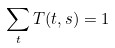<formula> <loc_0><loc_0><loc_500><loc_500>\sum _ { t } T ( t , s ) = 1</formula> 